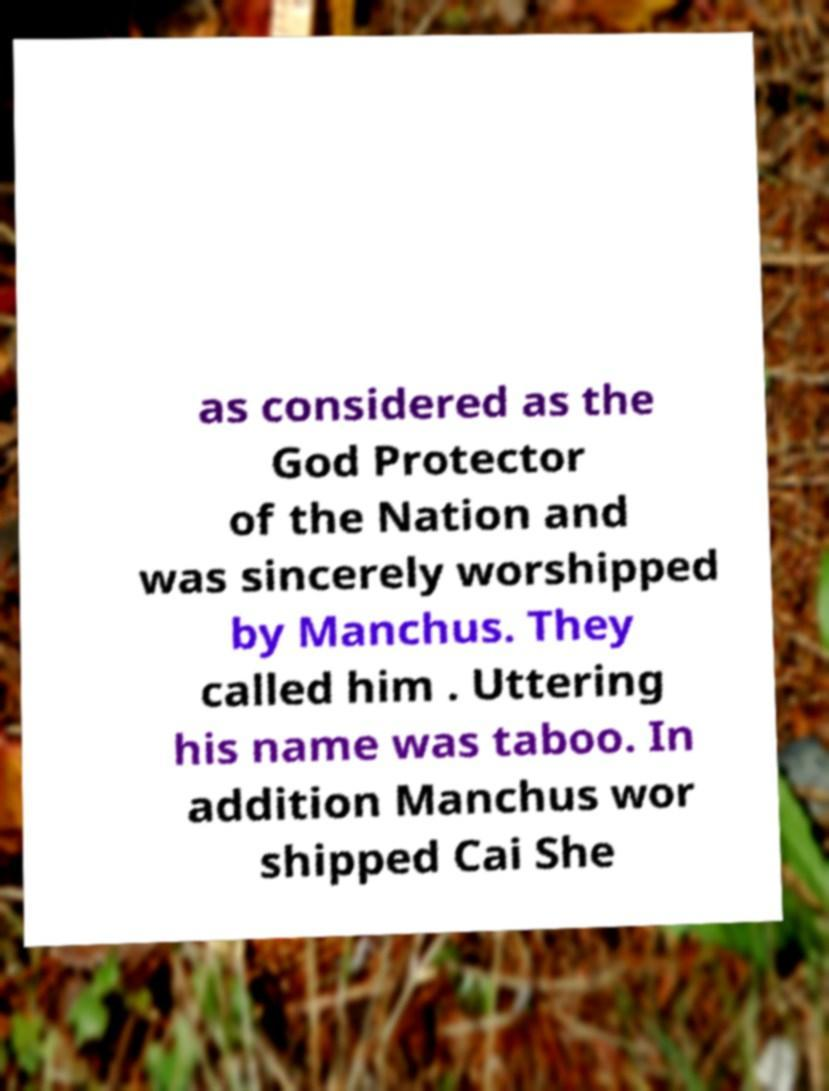I need the written content from this picture converted into text. Can you do that? as considered as the God Protector of the Nation and was sincerely worshipped by Manchus. They called him . Uttering his name was taboo. In addition Manchus wor shipped Cai She 